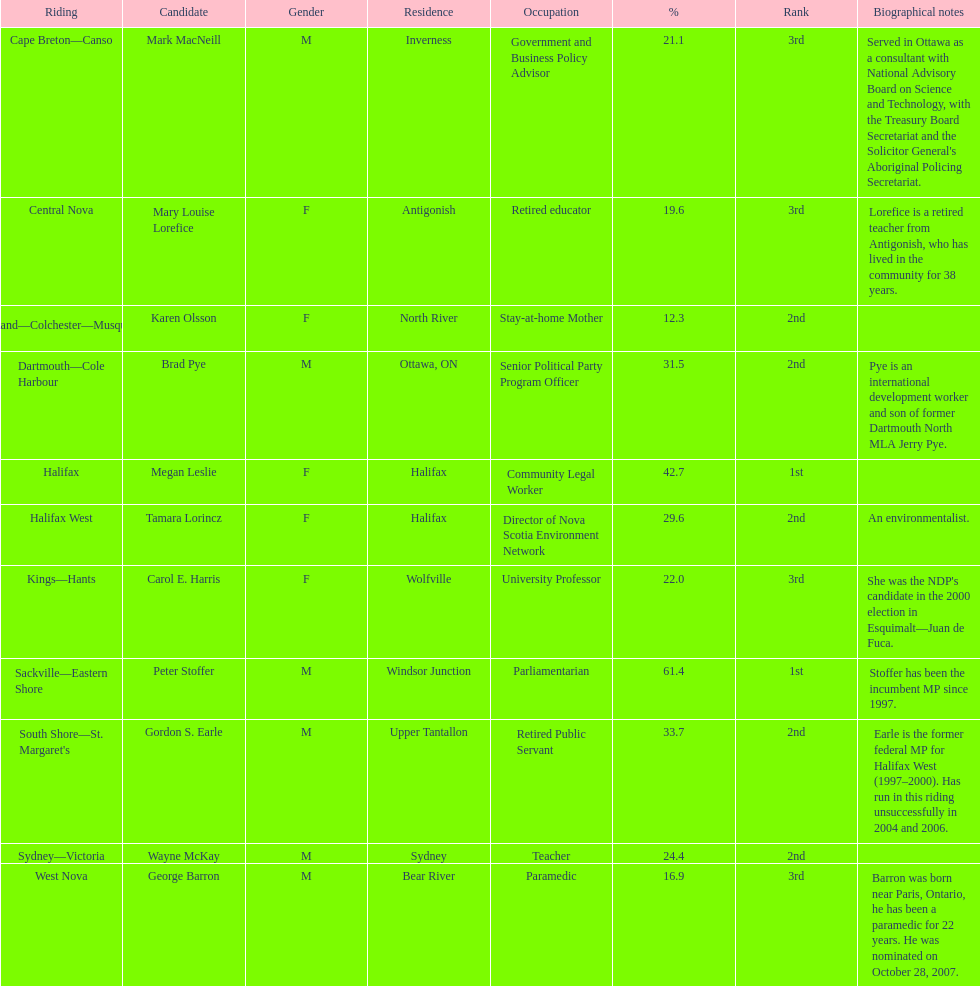Who received the least amount of votes? Karen Olsson. 